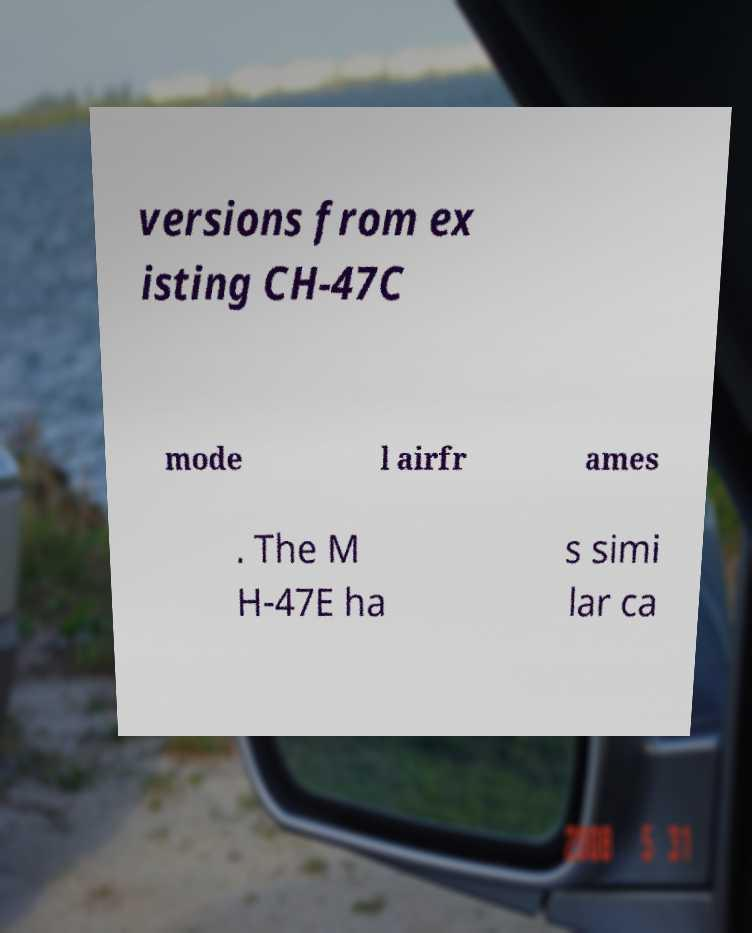I need the written content from this picture converted into text. Can you do that? versions from ex isting CH-47C mode l airfr ames . The M H-47E ha s simi lar ca 